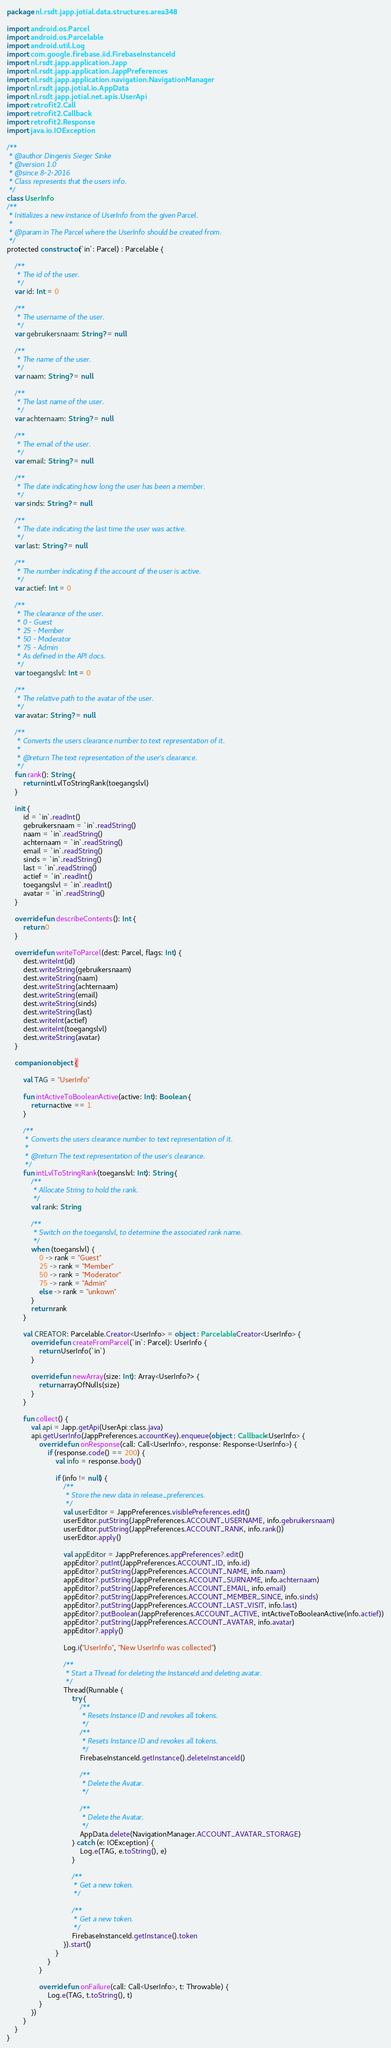Convert code to text. <code><loc_0><loc_0><loc_500><loc_500><_Kotlin_>package nl.rsdt.japp.jotial.data.structures.area348

import android.os.Parcel
import android.os.Parcelable
import android.util.Log
import com.google.firebase.iid.FirebaseInstanceId
import nl.rsdt.japp.application.Japp
import nl.rsdt.japp.application.JappPreferences
import nl.rsdt.japp.application.navigation.NavigationManager
import nl.rsdt.japp.jotial.io.AppData
import nl.rsdt.japp.jotial.net.apis.UserApi
import retrofit2.Call
import retrofit2.Callback
import retrofit2.Response
import java.io.IOException

/**
 * @author Dingenis Sieger Sinke
 * @version 1.0
 * @since 8-2-2016
 * Class represents that the users info.
 */
class UserInfo
/**
 * Initializes a new instance of UserInfo from the given Parcel.
 *
 * @param in The Parcel where the UserInfo should be created from.
 */
protected constructor(`in`: Parcel) : Parcelable {

    /**
     * The id of the user.
     */
    var id: Int = 0

    /**
     * The username of the user.
     */
    var gebruikersnaam: String? = null

    /**
     * The name of the user.
     */
    var naam: String? = null

    /**
     * The last name of the user.
     */
    var achternaam: String? = null

    /**
     * The email of the user.
     */
    var email: String? = null

    /**
     * The date indicating how long the user has been a member.
     */
    var sinds: String? = null

    /**
     * The date indicating the last time the user was active.
     */
    var last: String? = null

    /**
     * The number indicating if the account of the user is active.
     */
    var actief: Int = 0

    /**
     * The clearance of the user.
     * 0 - Guest
     * 25 - Member
     * 50 - Moderator
     * 75 - Admin
     * As defined in the API docs.
     */
    var toegangslvl: Int = 0

    /**
     * The relative path to the avatar of the user.
     */
    var avatar: String? = null

    /**
     * Converts the users clearance number to text representation of it.
     *
     * @return The text representation of the user's clearance.
     */
    fun rank(): String {
        return intLvlToStringRank(toegangslvl)
    }

    init {
        id = `in`.readInt()
        gebruikersnaam = `in`.readString()
        naam = `in`.readString()
        achternaam = `in`.readString()
        email = `in`.readString()
        sinds = `in`.readString()
        last = `in`.readString()
        actief = `in`.readInt()
        toegangslvl = `in`.readInt()
        avatar = `in`.readString()
    }

    override fun describeContents(): Int {
        return 0
    }

    override fun writeToParcel(dest: Parcel, flags: Int) {
        dest.writeInt(id)
        dest.writeString(gebruikersnaam)
        dest.writeString(naam)
        dest.writeString(achternaam)
        dest.writeString(email)
        dest.writeString(sinds)
        dest.writeString(last)
        dest.writeInt(actief)
        dest.writeInt(toegangslvl)
        dest.writeString(avatar)
    }

    companion object {

        val TAG = "UserInfo"

        fun intActiveToBooleanActive(active: Int): Boolean {
            return active == 1
        }

        /**
         * Converts the users clearance number to text representation of it.
         *
         * @return The text representation of the user's clearance.
         */
        fun intLvlToStringRank(toeganslvl: Int): String {
            /**
             * Allocate String to hold the rank.
             */
            val rank: String

            /**
             * Switch on the toeganslvl, to determine the associated rank name.
             */
            when (toeganslvl) {
                0 -> rank = "Guest"
                25 -> rank = "Member"
                50 -> rank = "Moderator"
                75 -> rank = "Admin"
                else -> rank = "unkown"
            }
            return rank
        }

        val CREATOR: Parcelable.Creator<UserInfo> = object : Parcelable.Creator<UserInfo> {
            override fun createFromParcel(`in`: Parcel): UserInfo {
                return UserInfo(`in`)
            }

            override fun newArray(size: Int): Array<UserInfo?> {
                return arrayOfNulls(size)
            }
        }

        fun collect() {
            val api = Japp.getApi(UserApi::class.java)
            api.getUserInfo(JappPreferences.accountKey).enqueue(object : Callback<UserInfo> {
                override fun onResponse(call: Call<UserInfo>, response: Response<UserInfo>) {
                    if (response.code() == 200) {
                        val info = response.body()

                        if (info != null) {
                            /**
                             * Store the new data in release_preferences.
                             */
                            val userEditor = JappPreferences.visiblePreferences.edit()
                            userEditor.putString(JappPreferences.ACCOUNT_USERNAME, info.gebruikersnaam)
                            userEditor.putString(JappPreferences.ACCOUNT_RANK, info.rank())
                            userEditor.apply()

                            val appEditor = JappPreferences.appPreferences?.edit()
                            appEditor?.putInt(JappPreferences.ACCOUNT_ID, info.id)
                            appEditor?.putString(JappPreferences.ACCOUNT_NAME, info.naam)
                            appEditor?.putString(JappPreferences.ACCOUNT_SURNAME, info.achternaam)
                            appEditor?.putString(JappPreferences.ACCOUNT_EMAIL, info.email)
                            appEditor?.putString(JappPreferences.ACCOUNT_MEMBER_SINCE, info.sinds)
                            appEditor?.putString(JappPreferences.ACCOUNT_LAST_VISIT, info.last)
                            appEditor?.putBoolean(JappPreferences.ACCOUNT_ACTIVE, intActiveToBooleanActive(info.actief))
                            appEditor?.putString(JappPreferences.ACCOUNT_AVATAR, info.avatar)
                            appEditor?.apply()

                            Log.i("UserInfo", "New UserInfo was collected")

                            /**
                             * Start a Thread for deleting the InstanceId and deleting avatar.
                             */
                            Thread(Runnable {
                                try {
                                    /**
                                     * Resets Instance ID and revokes all tokens.
                                     */
                                    /**
                                     * Resets Instance ID and revokes all tokens.
                                     */
                                    FirebaseInstanceId.getInstance().deleteInstanceId()

                                    /**
                                     * Delete the Avatar.
                                     */

                                    /**
                                     * Delete the Avatar.
                                     */
                                    AppData.delete(NavigationManager.ACCOUNT_AVATAR_STORAGE)
                                } catch (e: IOException) {
                                    Log.e(TAG, e.toString(), e)
                                }

                                /**
                                 * Get a new token.
                                 */

                                /**
                                 * Get a new token.
                                 */
                                FirebaseInstanceId.getInstance().token
                            }).start()
                        }
                    }
                }

                override fun onFailure(call: Call<UserInfo>, t: Throwable) {
                    Log.e(TAG, t.toString(), t)
                }
            })
        }
    }
}
</code> 